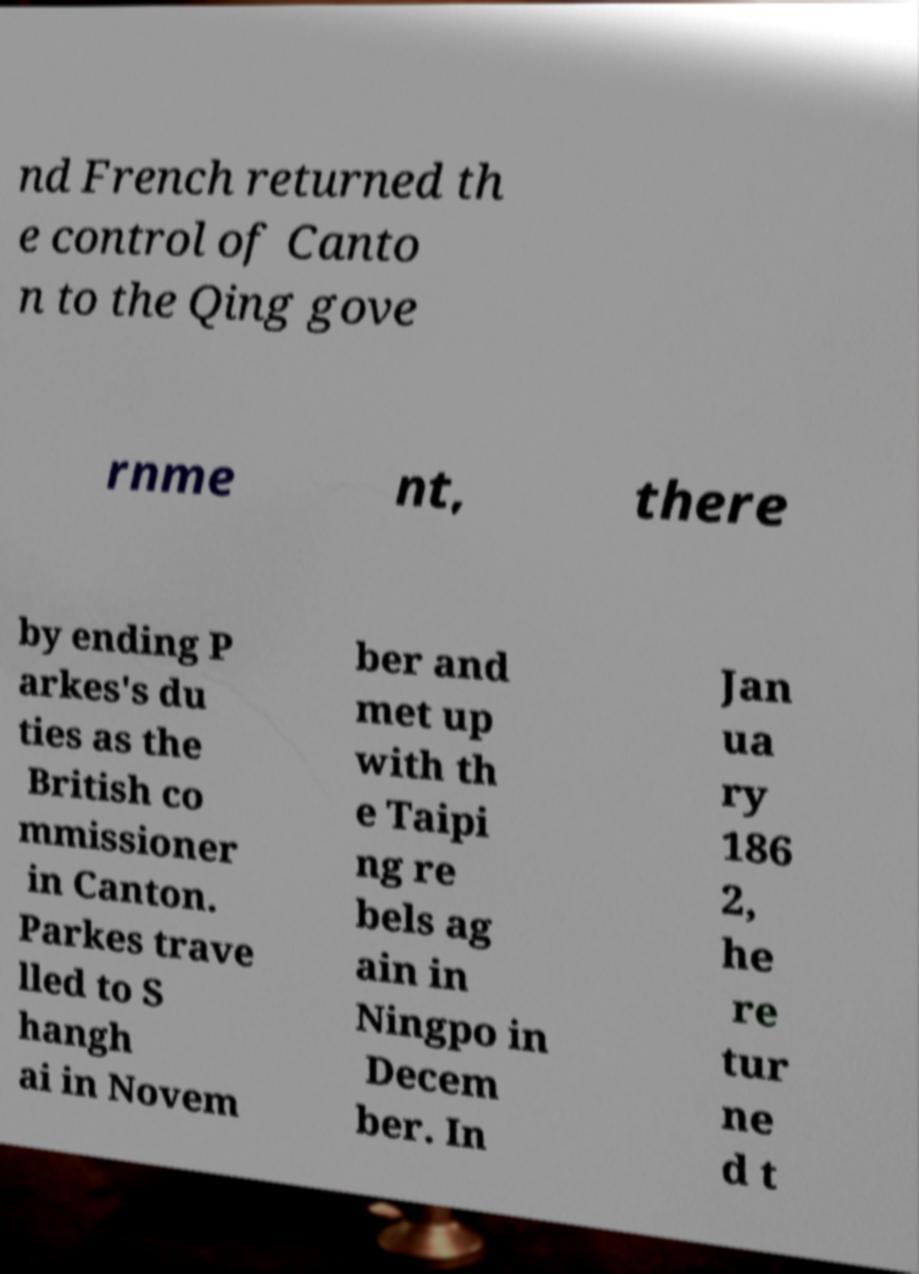Could you assist in decoding the text presented in this image and type it out clearly? nd French returned th e control of Canto n to the Qing gove rnme nt, there by ending P arkes's du ties as the British co mmissioner in Canton. Parkes trave lled to S hangh ai in Novem ber and met up with th e Taipi ng re bels ag ain in Ningpo in Decem ber. In Jan ua ry 186 2, he re tur ne d t 